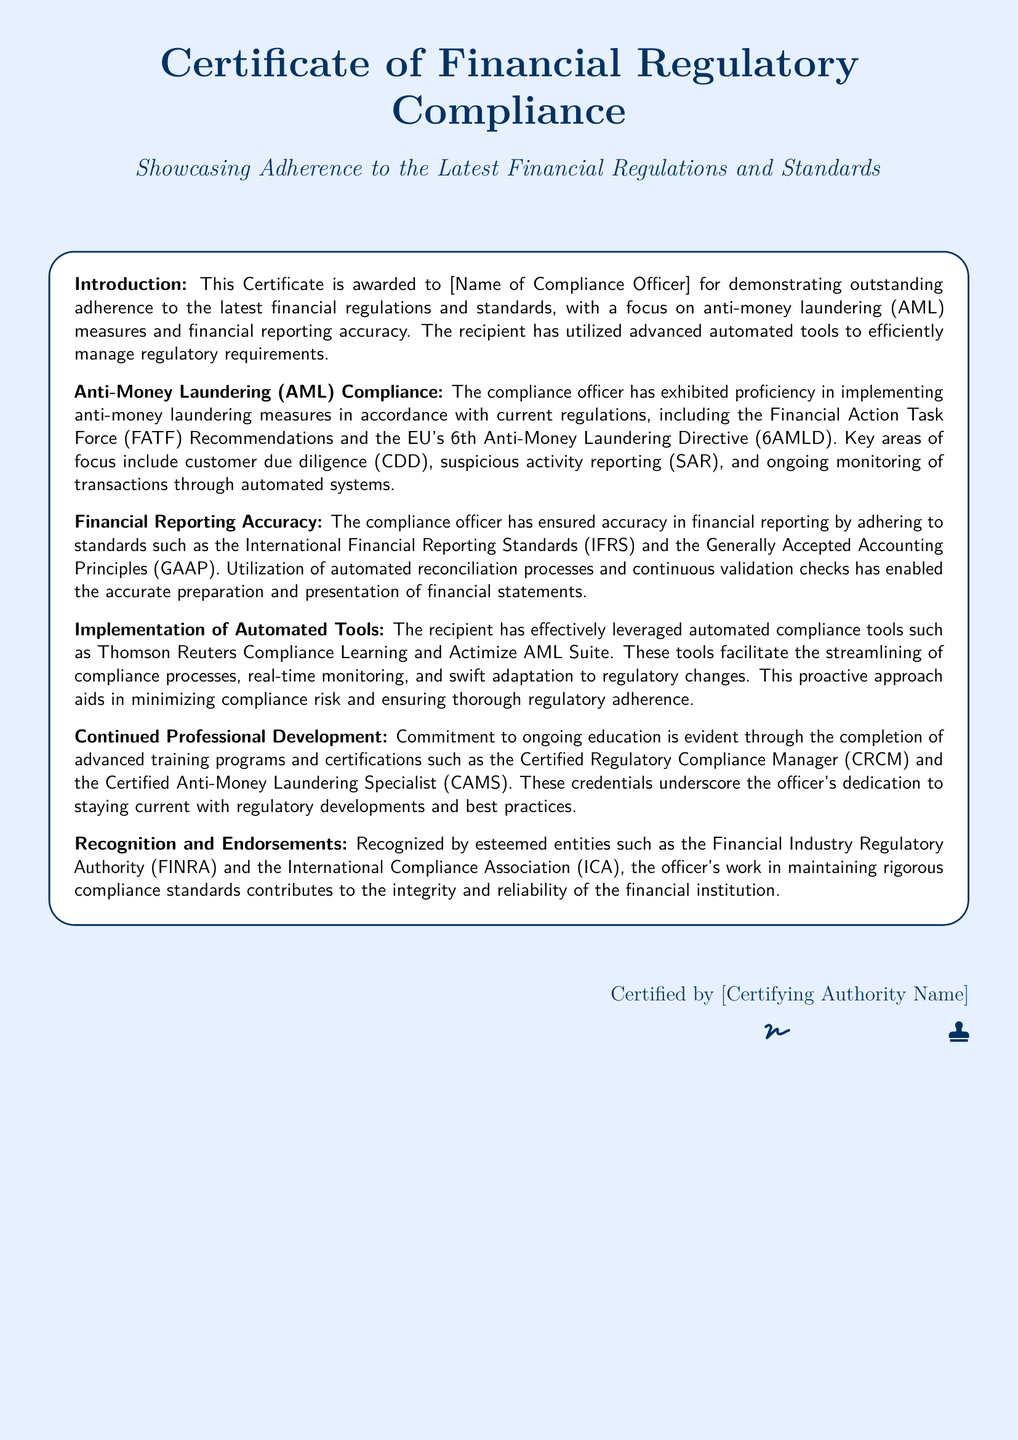What is the title of the certificate? The title is clearly stated at the top of the document, which is “Certificate of Financial Regulatory Compliance.”
Answer: Certificate of Financial Regulatory Compliance Who is the certificate awarded to? The document specifies the recipient at the beginning of the introduction section, highlighted as “[Name of Compliance Officer].”
Answer: [Name of Compliance Officer] Which anti-money laundering directive is mentioned? The document references current AML regulations, specifically the EU's 6th Anti-Money Laundering Directive (6AMLD).
Answer: 6AMLD What standards are adhered to for financial reporting accuracy? The document lists the adherence to International Financial Reporting Standards (IFRS) and Generally Accepted Accounting Principles (GAAP).
Answer: IFRS and GAAP What automated compliance tool is mentioned for AML? The document mentions the Actimize AML Suite as an automated compliance tool used for AML.
Answer: Actimize AML Suite Which training program is completed for continued professional development? The document cites the completion of the Certified Regulatory Compliance Manager (CRCM) program as part of continued education.
Answer: Certified Regulatory Compliance Manager What is the certifying authority's role? The certifying authority is mentioned as the entity that certifies the compliance officer’s adherence to standards in the document.
Answer: [Certifying Authority Name] Which organization's recognition is noted in the certificate? The document mentions recognition from the Financial Industry Regulatory Authority (FINRA).
Answer: FINRA 